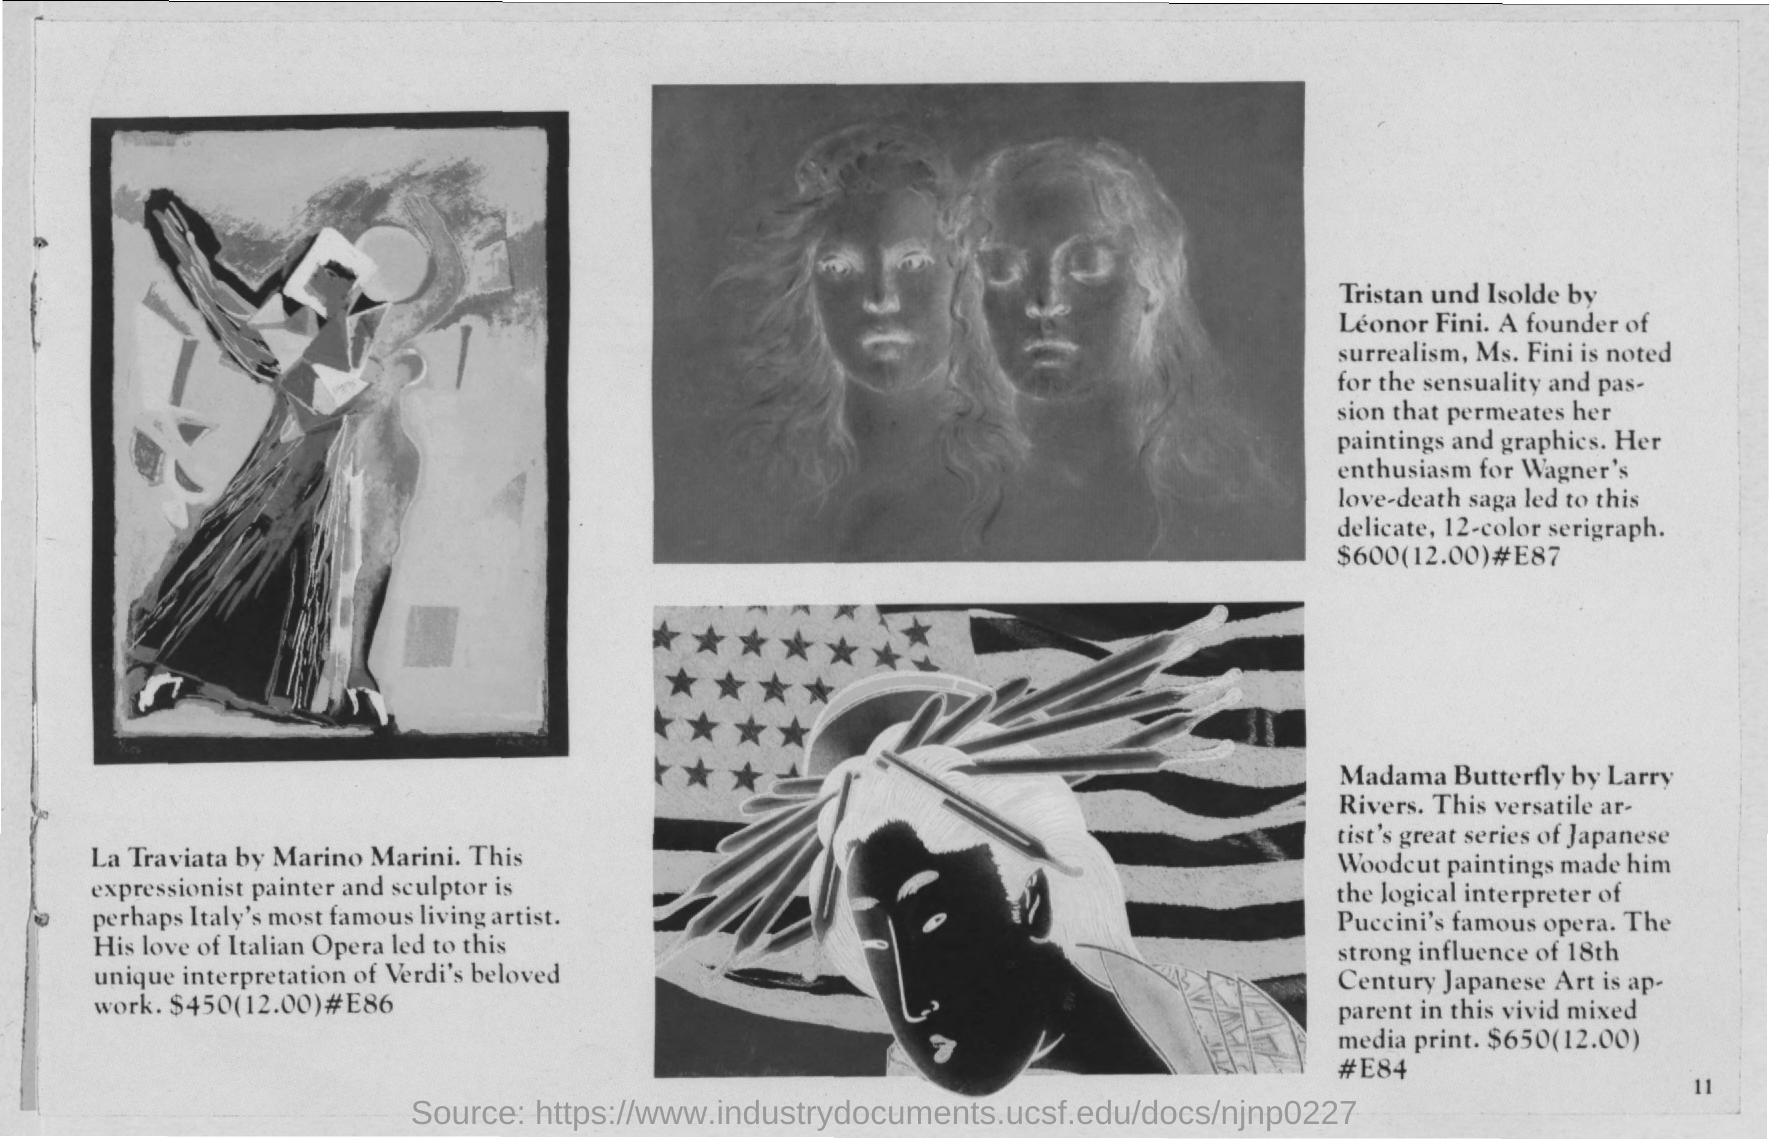Highlight a few significant elements in this photo. The work of Leonor Fini that is depicted is "Tristan und Isolde. La Traviata is available for $450. The painting "Madama Butterfly" is the work of Larry Rivers. Marino Marini is the artist who created the artwork titled La Traviata. 